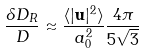<formula> <loc_0><loc_0><loc_500><loc_500>\frac { \delta D _ { R } } { D } \approx \frac { \langle | { \mathbf u } | ^ { 2 } \rangle } { a _ { 0 } ^ { 2 } } \frac { 4 \pi } { 5 \sqrt { 3 } }</formula> 